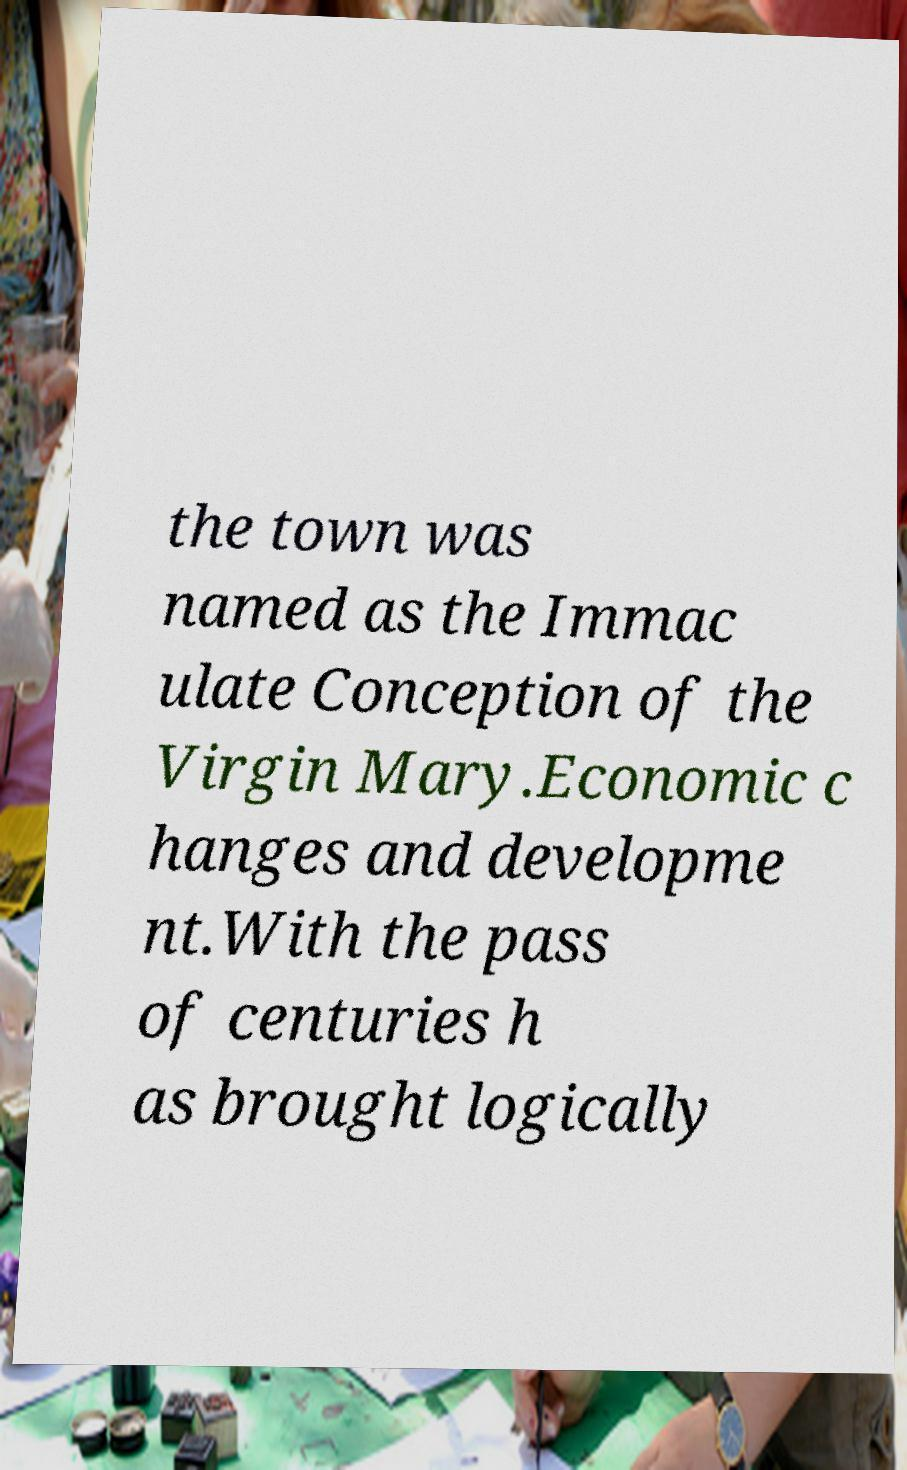Can you accurately transcribe the text from the provided image for me? the town was named as the Immac ulate Conception of the Virgin Mary.Economic c hanges and developme nt.With the pass of centuries h as brought logically 